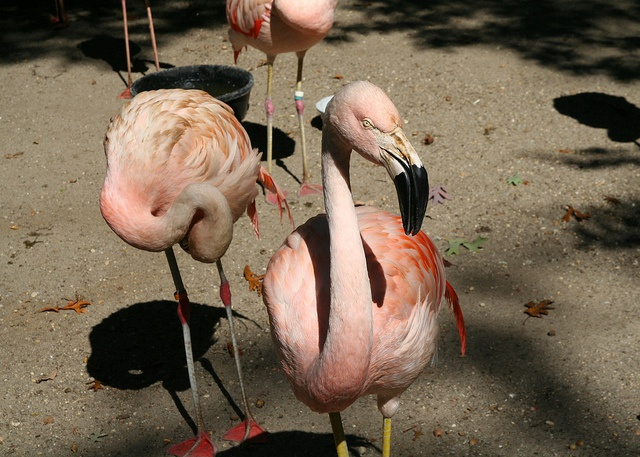Describe the objects in this image and their specific colors. I can see bird in black, tan, and lightgray tones, bird in black, tan, and gray tones, bird in black, maroon, tan, and gray tones, and bird in black, gray, maroon, and salmon tones in this image. 